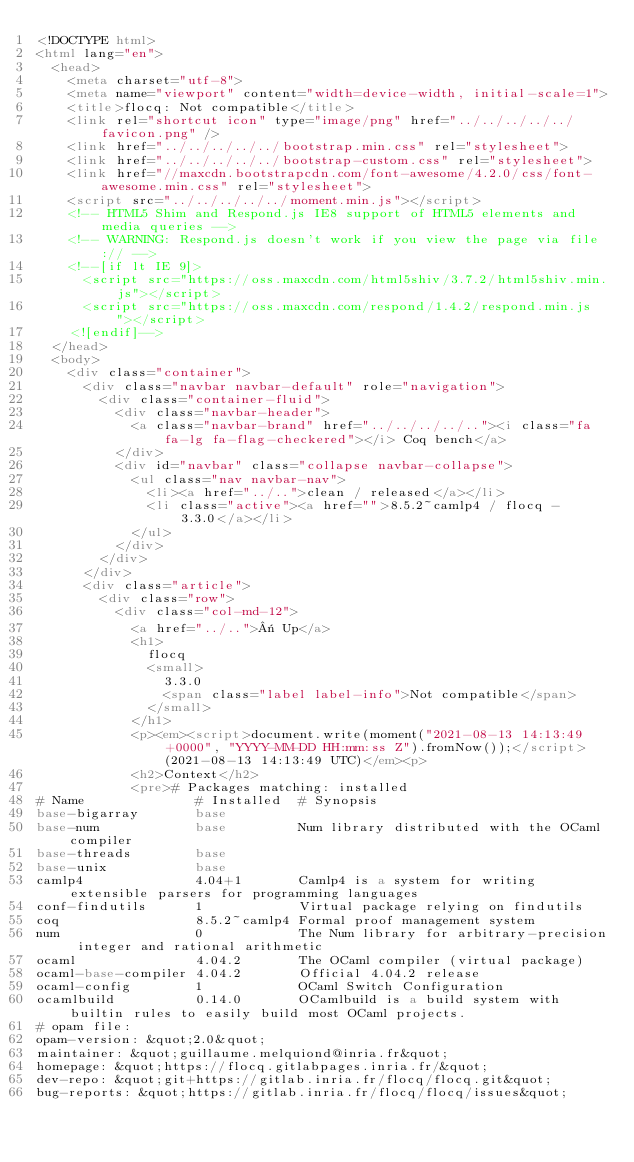<code> <loc_0><loc_0><loc_500><loc_500><_HTML_><!DOCTYPE html>
<html lang="en">
  <head>
    <meta charset="utf-8">
    <meta name="viewport" content="width=device-width, initial-scale=1">
    <title>flocq: Not compatible</title>
    <link rel="shortcut icon" type="image/png" href="../../../../../favicon.png" />
    <link href="../../../../../bootstrap.min.css" rel="stylesheet">
    <link href="../../../../../bootstrap-custom.css" rel="stylesheet">
    <link href="//maxcdn.bootstrapcdn.com/font-awesome/4.2.0/css/font-awesome.min.css" rel="stylesheet">
    <script src="../../../../../moment.min.js"></script>
    <!-- HTML5 Shim and Respond.js IE8 support of HTML5 elements and media queries -->
    <!-- WARNING: Respond.js doesn't work if you view the page via file:// -->
    <!--[if lt IE 9]>
      <script src="https://oss.maxcdn.com/html5shiv/3.7.2/html5shiv.min.js"></script>
      <script src="https://oss.maxcdn.com/respond/1.4.2/respond.min.js"></script>
    <![endif]-->
  </head>
  <body>
    <div class="container">
      <div class="navbar navbar-default" role="navigation">
        <div class="container-fluid">
          <div class="navbar-header">
            <a class="navbar-brand" href="../../../../.."><i class="fa fa-lg fa-flag-checkered"></i> Coq bench</a>
          </div>
          <div id="navbar" class="collapse navbar-collapse">
            <ul class="nav navbar-nav">
              <li><a href="../..">clean / released</a></li>
              <li class="active"><a href="">8.5.2~camlp4 / flocq - 3.3.0</a></li>
            </ul>
          </div>
        </div>
      </div>
      <div class="article">
        <div class="row">
          <div class="col-md-12">
            <a href="../..">« Up</a>
            <h1>
              flocq
              <small>
                3.3.0
                <span class="label label-info">Not compatible</span>
              </small>
            </h1>
            <p><em><script>document.write(moment("2021-08-13 14:13:49 +0000", "YYYY-MM-DD HH:mm:ss Z").fromNow());</script> (2021-08-13 14:13:49 UTC)</em><p>
            <h2>Context</h2>
            <pre># Packages matching: installed
# Name              # Installed  # Synopsis
base-bigarray       base
base-num            base         Num library distributed with the OCaml compiler
base-threads        base
base-unix           base
camlp4              4.04+1       Camlp4 is a system for writing extensible parsers for programming languages
conf-findutils      1            Virtual package relying on findutils
coq                 8.5.2~camlp4 Formal proof management system
num                 0            The Num library for arbitrary-precision integer and rational arithmetic
ocaml               4.04.2       The OCaml compiler (virtual package)
ocaml-base-compiler 4.04.2       Official 4.04.2 release
ocaml-config        1            OCaml Switch Configuration
ocamlbuild          0.14.0       OCamlbuild is a build system with builtin rules to easily build most OCaml projects.
# opam file:
opam-version: &quot;2.0&quot;
maintainer: &quot;guillaume.melquiond@inria.fr&quot;
homepage: &quot;https://flocq.gitlabpages.inria.fr/&quot;
dev-repo: &quot;git+https://gitlab.inria.fr/flocq/flocq.git&quot;
bug-reports: &quot;https://gitlab.inria.fr/flocq/flocq/issues&quot;</code> 